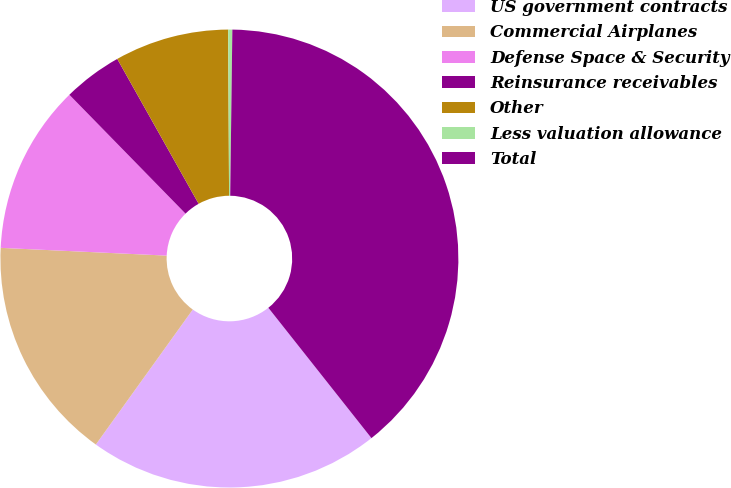Convert chart to OTSL. <chart><loc_0><loc_0><loc_500><loc_500><pie_chart><fcel>US government contracts<fcel>Commercial Airplanes<fcel>Defense Space & Security<fcel>Reinsurance receivables<fcel>Other<fcel>Less valuation allowance<fcel>Total<nl><fcel>20.56%<fcel>15.83%<fcel>11.94%<fcel>4.17%<fcel>8.06%<fcel>0.29%<fcel>39.14%<nl></chart> 